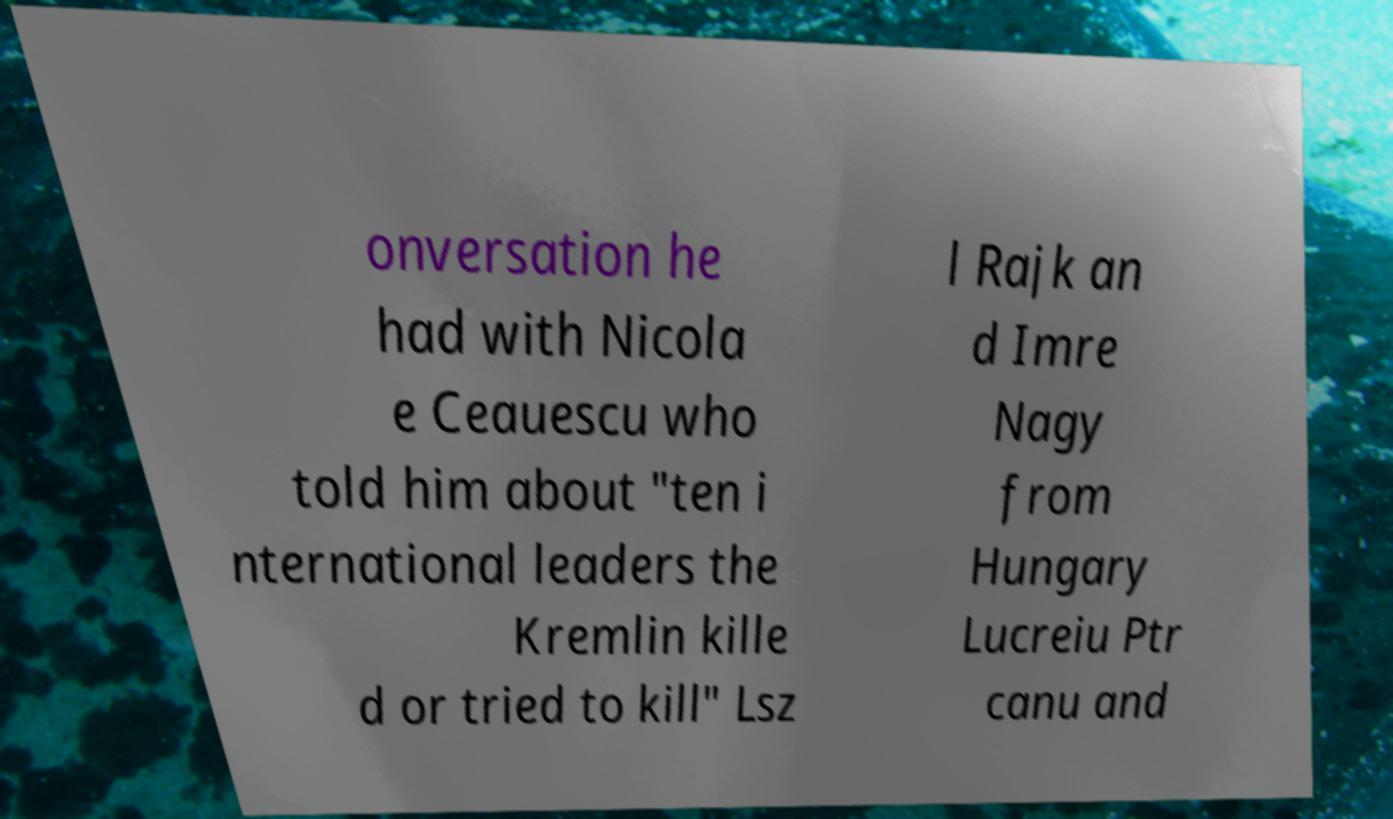I need the written content from this picture converted into text. Can you do that? onversation he had with Nicola e Ceauescu who told him about "ten i nternational leaders the Kremlin kille d or tried to kill" Lsz l Rajk an d Imre Nagy from Hungary Lucreiu Ptr canu and 